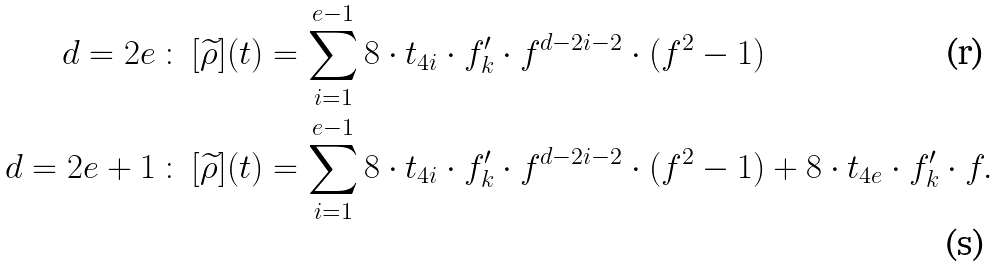<formula> <loc_0><loc_0><loc_500><loc_500>d = 2 e \, \colon \, [ \widetilde { \rho } ] ( t ) & = \sum _ { i = 1 } ^ { e - 1 } 8 \cdot t _ { 4 i } \cdot f ^ { \prime } _ { k } \cdot f ^ { d - 2 i - 2 } \cdot ( f ^ { 2 } - 1 ) \\ d = 2 e + 1 \, \colon \, [ \widetilde { \rho } ] ( t ) & = \sum _ { i = 1 } ^ { e - 1 } 8 \cdot t _ { 4 i } \cdot f ^ { \prime } _ { k } \cdot f ^ { d - 2 i - 2 } \cdot ( f ^ { 2 } - 1 ) + 8 \cdot t _ { 4 e } \cdot f ^ { \prime } _ { k } \cdot f .</formula> 